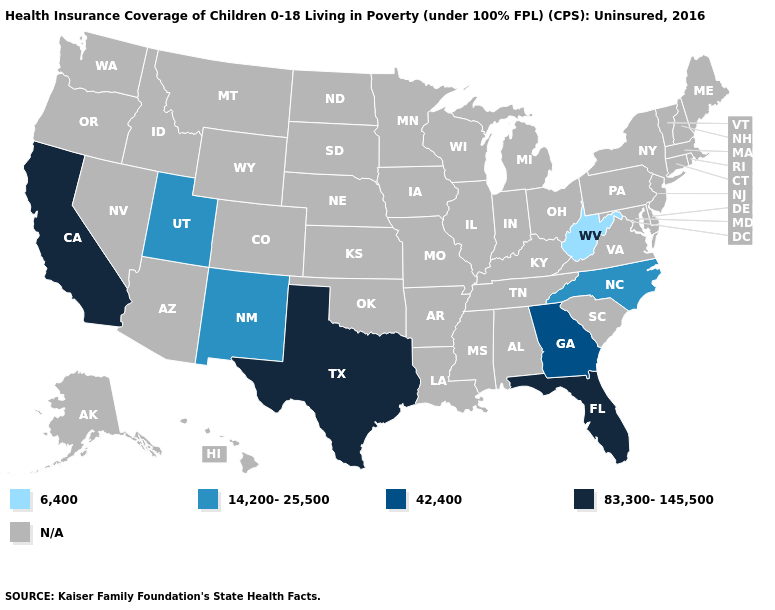Name the states that have a value in the range 42,400?
Answer briefly. Georgia. Which states hav the highest value in the West?
Quick response, please. California. Is the legend a continuous bar?
Short answer required. No. Name the states that have a value in the range 42,400?
Keep it brief. Georgia. Does the map have missing data?
Write a very short answer. Yes. Name the states that have a value in the range 14,200-25,500?
Short answer required. New Mexico, North Carolina, Utah. Name the states that have a value in the range 83,300-145,500?
Concise answer only. California, Florida, Texas. What is the value of Wyoming?
Keep it brief. N/A. Does West Virginia have the lowest value in the USA?
Be succinct. Yes. Name the states that have a value in the range 83,300-145,500?
Short answer required. California, Florida, Texas. Which states have the lowest value in the USA?
Keep it brief. West Virginia. What is the highest value in the West ?
Answer briefly. 83,300-145,500. 